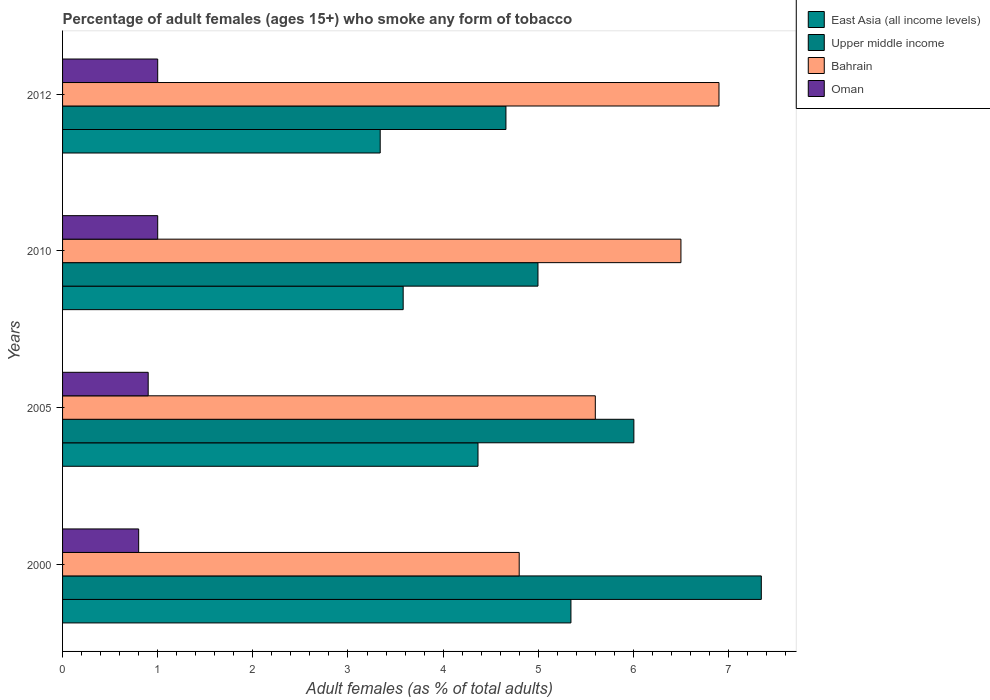How many different coloured bars are there?
Provide a succinct answer. 4. Are the number of bars per tick equal to the number of legend labels?
Your answer should be very brief. Yes. Are the number of bars on each tick of the Y-axis equal?
Your answer should be very brief. Yes. How many bars are there on the 3rd tick from the top?
Make the answer very short. 4. What is the label of the 4th group of bars from the top?
Offer a very short reply. 2000. In how many cases, is the number of bars for a given year not equal to the number of legend labels?
Offer a terse response. 0. What is the percentage of adult females who smoke in Upper middle income in 2000?
Offer a very short reply. 7.35. Across all years, what is the maximum percentage of adult females who smoke in East Asia (all income levels)?
Provide a short and direct response. 5.34. What is the difference between the percentage of adult females who smoke in Upper middle income in 2005 and that in 2012?
Ensure brevity in your answer.  1.34. What is the difference between the percentage of adult females who smoke in Bahrain in 2010 and the percentage of adult females who smoke in Upper middle income in 2005?
Your answer should be compact. 0.49. What is the average percentage of adult females who smoke in East Asia (all income levels) per year?
Keep it short and to the point. 4.16. In the year 2012, what is the difference between the percentage of adult females who smoke in Oman and percentage of adult females who smoke in East Asia (all income levels)?
Your answer should be compact. -2.34. In how many years, is the percentage of adult females who smoke in Upper middle income greater than 6.4 %?
Keep it short and to the point. 1. What is the ratio of the percentage of adult females who smoke in Bahrain in 2005 to that in 2012?
Ensure brevity in your answer.  0.81. Is the difference between the percentage of adult females who smoke in Oman in 2010 and 2012 greater than the difference between the percentage of adult females who smoke in East Asia (all income levels) in 2010 and 2012?
Ensure brevity in your answer.  No. What is the difference between the highest and the second highest percentage of adult females who smoke in Bahrain?
Provide a short and direct response. 0.4. What is the difference between the highest and the lowest percentage of adult females who smoke in Upper middle income?
Provide a succinct answer. 2.68. Is it the case that in every year, the sum of the percentage of adult females who smoke in Bahrain and percentage of adult females who smoke in East Asia (all income levels) is greater than the sum of percentage of adult females who smoke in Oman and percentage of adult females who smoke in Upper middle income?
Provide a succinct answer. Yes. What does the 4th bar from the top in 2010 represents?
Your answer should be very brief. East Asia (all income levels). What does the 4th bar from the bottom in 2000 represents?
Your answer should be very brief. Oman. Is it the case that in every year, the sum of the percentage of adult females who smoke in East Asia (all income levels) and percentage of adult females who smoke in Oman is greater than the percentage of adult females who smoke in Bahrain?
Ensure brevity in your answer.  No. How many bars are there?
Make the answer very short. 16. How many years are there in the graph?
Keep it short and to the point. 4. What is the difference between two consecutive major ticks on the X-axis?
Your answer should be compact. 1. Are the values on the major ticks of X-axis written in scientific E-notation?
Your answer should be compact. No. Does the graph contain any zero values?
Ensure brevity in your answer.  No. Where does the legend appear in the graph?
Your answer should be very brief. Top right. What is the title of the graph?
Keep it short and to the point. Percentage of adult females (ages 15+) who smoke any form of tobacco. Does "Iraq" appear as one of the legend labels in the graph?
Ensure brevity in your answer.  No. What is the label or title of the X-axis?
Offer a very short reply. Adult females (as % of total adults). What is the label or title of the Y-axis?
Offer a very short reply. Years. What is the Adult females (as % of total adults) of East Asia (all income levels) in 2000?
Your response must be concise. 5.34. What is the Adult females (as % of total adults) of Upper middle income in 2000?
Your response must be concise. 7.35. What is the Adult females (as % of total adults) of Oman in 2000?
Offer a terse response. 0.8. What is the Adult females (as % of total adults) of East Asia (all income levels) in 2005?
Your response must be concise. 4.37. What is the Adult females (as % of total adults) of Upper middle income in 2005?
Your answer should be compact. 6.01. What is the Adult females (as % of total adults) of Bahrain in 2005?
Give a very brief answer. 5.6. What is the Adult females (as % of total adults) of Oman in 2005?
Offer a terse response. 0.9. What is the Adult females (as % of total adults) of East Asia (all income levels) in 2010?
Make the answer very short. 3.58. What is the Adult females (as % of total adults) of Upper middle income in 2010?
Provide a succinct answer. 5. What is the Adult females (as % of total adults) of East Asia (all income levels) in 2012?
Make the answer very short. 3.34. What is the Adult females (as % of total adults) in Upper middle income in 2012?
Your answer should be very brief. 4.66. What is the Adult females (as % of total adults) in Bahrain in 2012?
Give a very brief answer. 6.9. Across all years, what is the maximum Adult females (as % of total adults) of East Asia (all income levels)?
Make the answer very short. 5.34. Across all years, what is the maximum Adult females (as % of total adults) of Upper middle income?
Your answer should be very brief. 7.35. Across all years, what is the maximum Adult females (as % of total adults) of Oman?
Provide a succinct answer. 1. Across all years, what is the minimum Adult females (as % of total adults) in East Asia (all income levels)?
Offer a terse response. 3.34. Across all years, what is the minimum Adult females (as % of total adults) in Upper middle income?
Provide a short and direct response. 4.66. Across all years, what is the minimum Adult females (as % of total adults) in Bahrain?
Provide a short and direct response. 4.8. What is the total Adult females (as % of total adults) in East Asia (all income levels) in the graph?
Give a very brief answer. 16.63. What is the total Adult females (as % of total adults) of Upper middle income in the graph?
Offer a very short reply. 23.01. What is the total Adult females (as % of total adults) of Bahrain in the graph?
Ensure brevity in your answer.  23.8. What is the difference between the Adult females (as % of total adults) of East Asia (all income levels) in 2000 and that in 2005?
Offer a terse response. 0.98. What is the difference between the Adult females (as % of total adults) of Upper middle income in 2000 and that in 2005?
Your response must be concise. 1.34. What is the difference between the Adult females (as % of total adults) of East Asia (all income levels) in 2000 and that in 2010?
Provide a short and direct response. 1.76. What is the difference between the Adult females (as % of total adults) in Upper middle income in 2000 and that in 2010?
Keep it short and to the point. 2.35. What is the difference between the Adult females (as % of total adults) of East Asia (all income levels) in 2000 and that in 2012?
Your answer should be compact. 2. What is the difference between the Adult females (as % of total adults) of Upper middle income in 2000 and that in 2012?
Provide a succinct answer. 2.68. What is the difference between the Adult females (as % of total adults) in Bahrain in 2000 and that in 2012?
Your answer should be very brief. -2.1. What is the difference between the Adult females (as % of total adults) in East Asia (all income levels) in 2005 and that in 2010?
Ensure brevity in your answer.  0.79. What is the difference between the Adult females (as % of total adults) in Upper middle income in 2005 and that in 2010?
Make the answer very short. 1.01. What is the difference between the Adult females (as % of total adults) in East Asia (all income levels) in 2005 and that in 2012?
Offer a terse response. 1.03. What is the difference between the Adult females (as % of total adults) in Upper middle income in 2005 and that in 2012?
Your answer should be compact. 1.34. What is the difference between the Adult females (as % of total adults) in Bahrain in 2005 and that in 2012?
Make the answer very short. -1.3. What is the difference between the Adult females (as % of total adults) in East Asia (all income levels) in 2010 and that in 2012?
Offer a terse response. 0.24. What is the difference between the Adult females (as % of total adults) of Upper middle income in 2010 and that in 2012?
Your answer should be very brief. 0.34. What is the difference between the Adult females (as % of total adults) in Bahrain in 2010 and that in 2012?
Provide a short and direct response. -0.4. What is the difference between the Adult females (as % of total adults) in East Asia (all income levels) in 2000 and the Adult females (as % of total adults) in Upper middle income in 2005?
Keep it short and to the point. -0.66. What is the difference between the Adult females (as % of total adults) of East Asia (all income levels) in 2000 and the Adult females (as % of total adults) of Bahrain in 2005?
Make the answer very short. -0.26. What is the difference between the Adult females (as % of total adults) in East Asia (all income levels) in 2000 and the Adult females (as % of total adults) in Oman in 2005?
Offer a very short reply. 4.44. What is the difference between the Adult females (as % of total adults) in Upper middle income in 2000 and the Adult females (as % of total adults) in Bahrain in 2005?
Provide a succinct answer. 1.75. What is the difference between the Adult females (as % of total adults) of Upper middle income in 2000 and the Adult females (as % of total adults) of Oman in 2005?
Provide a short and direct response. 6.45. What is the difference between the Adult females (as % of total adults) of Bahrain in 2000 and the Adult females (as % of total adults) of Oman in 2005?
Ensure brevity in your answer.  3.9. What is the difference between the Adult females (as % of total adults) of East Asia (all income levels) in 2000 and the Adult females (as % of total adults) of Upper middle income in 2010?
Your answer should be very brief. 0.35. What is the difference between the Adult females (as % of total adults) of East Asia (all income levels) in 2000 and the Adult females (as % of total adults) of Bahrain in 2010?
Keep it short and to the point. -1.16. What is the difference between the Adult females (as % of total adults) in East Asia (all income levels) in 2000 and the Adult females (as % of total adults) in Oman in 2010?
Offer a very short reply. 4.34. What is the difference between the Adult females (as % of total adults) in Upper middle income in 2000 and the Adult females (as % of total adults) in Bahrain in 2010?
Offer a terse response. 0.84. What is the difference between the Adult females (as % of total adults) in Upper middle income in 2000 and the Adult females (as % of total adults) in Oman in 2010?
Your answer should be very brief. 6.34. What is the difference between the Adult females (as % of total adults) in East Asia (all income levels) in 2000 and the Adult females (as % of total adults) in Upper middle income in 2012?
Provide a short and direct response. 0.68. What is the difference between the Adult females (as % of total adults) in East Asia (all income levels) in 2000 and the Adult females (as % of total adults) in Bahrain in 2012?
Keep it short and to the point. -1.56. What is the difference between the Adult females (as % of total adults) of East Asia (all income levels) in 2000 and the Adult females (as % of total adults) of Oman in 2012?
Give a very brief answer. 4.34. What is the difference between the Adult females (as % of total adults) in Upper middle income in 2000 and the Adult females (as % of total adults) in Bahrain in 2012?
Provide a short and direct response. 0.45. What is the difference between the Adult females (as % of total adults) of Upper middle income in 2000 and the Adult females (as % of total adults) of Oman in 2012?
Give a very brief answer. 6.34. What is the difference between the Adult females (as % of total adults) in Bahrain in 2000 and the Adult females (as % of total adults) in Oman in 2012?
Your answer should be very brief. 3.8. What is the difference between the Adult females (as % of total adults) of East Asia (all income levels) in 2005 and the Adult females (as % of total adults) of Upper middle income in 2010?
Keep it short and to the point. -0.63. What is the difference between the Adult females (as % of total adults) in East Asia (all income levels) in 2005 and the Adult females (as % of total adults) in Bahrain in 2010?
Offer a very short reply. -2.13. What is the difference between the Adult females (as % of total adults) of East Asia (all income levels) in 2005 and the Adult females (as % of total adults) of Oman in 2010?
Offer a terse response. 3.37. What is the difference between the Adult females (as % of total adults) of Upper middle income in 2005 and the Adult females (as % of total adults) of Bahrain in 2010?
Provide a succinct answer. -0.49. What is the difference between the Adult females (as % of total adults) in Upper middle income in 2005 and the Adult females (as % of total adults) in Oman in 2010?
Ensure brevity in your answer.  5.01. What is the difference between the Adult females (as % of total adults) in Bahrain in 2005 and the Adult females (as % of total adults) in Oman in 2010?
Make the answer very short. 4.6. What is the difference between the Adult females (as % of total adults) of East Asia (all income levels) in 2005 and the Adult females (as % of total adults) of Upper middle income in 2012?
Your answer should be compact. -0.29. What is the difference between the Adult females (as % of total adults) in East Asia (all income levels) in 2005 and the Adult females (as % of total adults) in Bahrain in 2012?
Offer a very short reply. -2.53. What is the difference between the Adult females (as % of total adults) in East Asia (all income levels) in 2005 and the Adult females (as % of total adults) in Oman in 2012?
Your response must be concise. 3.37. What is the difference between the Adult females (as % of total adults) of Upper middle income in 2005 and the Adult females (as % of total adults) of Bahrain in 2012?
Ensure brevity in your answer.  -0.89. What is the difference between the Adult females (as % of total adults) in Upper middle income in 2005 and the Adult females (as % of total adults) in Oman in 2012?
Give a very brief answer. 5.01. What is the difference between the Adult females (as % of total adults) of Bahrain in 2005 and the Adult females (as % of total adults) of Oman in 2012?
Your answer should be very brief. 4.6. What is the difference between the Adult females (as % of total adults) of East Asia (all income levels) in 2010 and the Adult females (as % of total adults) of Upper middle income in 2012?
Your response must be concise. -1.08. What is the difference between the Adult females (as % of total adults) of East Asia (all income levels) in 2010 and the Adult females (as % of total adults) of Bahrain in 2012?
Keep it short and to the point. -3.32. What is the difference between the Adult females (as % of total adults) of East Asia (all income levels) in 2010 and the Adult females (as % of total adults) of Oman in 2012?
Keep it short and to the point. 2.58. What is the difference between the Adult females (as % of total adults) of Upper middle income in 2010 and the Adult females (as % of total adults) of Bahrain in 2012?
Keep it short and to the point. -1.9. What is the difference between the Adult females (as % of total adults) of Upper middle income in 2010 and the Adult females (as % of total adults) of Oman in 2012?
Make the answer very short. 4. What is the difference between the Adult females (as % of total adults) of Bahrain in 2010 and the Adult females (as % of total adults) of Oman in 2012?
Ensure brevity in your answer.  5.5. What is the average Adult females (as % of total adults) in East Asia (all income levels) per year?
Make the answer very short. 4.16. What is the average Adult females (as % of total adults) in Upper middle income per year?
Your response must be concise. 5.75. What is the average Adult females (as % of total adults) in Bahrain per year?
Offer a very short reply. 5.95. What is the average Adult females (as % of total adults) in Oman per year?
Provide a succinct answer. 0.93. In the year 2000, what is the difference between the Adult females (as % of total adults) of East Asia (all income levels) and Adult females (as % of total adults) of Upper middle income?
Make the answer very short. -2. In the year 2000, what is the difference between the Adult females (as % of total adults) of East Asia (all income levels) and Adult females (as % of total adults) of Bahrain?
Your answer should be very brief. 0.54. In the year 2000, what is the difference between the Adult females (as % of total adults) of East Asia (all income levels) and Adult females (as % of total adults) of Oman?
Your response must be concise. 4.54. In the year 2000, what is the difference between the Adult females (as % of total adults) of Upper middle income and Adult females (as % of total adults) of Bahrain?
Provide a short and direct response. 2.54. In the year 2000, what is the difference between the Adult females (as % of total adults) in Upper middle income and Adult females (as % of total adults) in Oman?
Keep it short and to the point. 6.54. In the year 2000, what is the difference between the Adult females (as % of total adults) of Bahrain and Adult females (as % of total adults) of Oman?
Your answer should be very brief. 4. In the year 2005, what is the difference between the Adult females (as % of total adults) in East Asia (all income levels) and Adult females (as % of total adults) in Upper middle income?
Provide a short and direct response. -1.64. In the year 2005, what is the difference between the Adult females (as % of total adults) in East Asia (all income levels) and Adult females (as % of total adults) in Bahrain?
Your answer should be compact. -1.23. In the year 2005, what is the difference between the Adult females (as % of total adults) of East Asia (all income levels) and Adult females (as % of total adults) of Oman?
Keep it short and to the point. 3.47. In the year 2005, what is the difference between the Adult females (as % of total adults) in Upper middle income and Adult females (as % of total adults) in Bahrain?
Keep it short and to the point. 0.41. In the year 2005, what is the difference between the Adult females (as % of total adults) in Upper middle income and Adult females (as % of total adults) in Oman?
Your response must be concise. 5.11. In the year 2005, what is the difference between the Adult females (as % of total adults) in Bahrain and Adult females (as % of total adults) in Oman?
Your response must be concise. 4.7. In the year 2010, what is the difference between the Adult females (as % of total adults) of East Asia (all income levels) and Adult females (as % of total adults) of Upper middle income?
Keep it short and to the point. -1.42. In the year 2010, what is the difference between the Adult females (as % of total adults) of East Asia (all income levels) and Adult females (as % of total adults) of Bahrain?
Provide a succinct answer. -2.92. In the year 2010, what is the difference between the Adult females (as % of total adults) of East Asia (all income levels) and Adult females (as % of total adults) of Oman?
Provide a short and direct response. 2.58. In the year 2010, what is the difference between the Adult females (as % of total adults) of Upper middle income and Adult females (as % of total adults) of Bahrain?
Provide a short and direct response. -1.5. In the year 2010, what is the difference between the Adult females (as % of total adults) of Upper middle income and Adult females (as % of total adults) of Oman?
Give a very brief answer. 4. In the year 2010, what is the difference between the Adult females (as % of total adults) in Bahrain and Adult females (as % of total adults) in Oman?
Provide a short and direct response. 5.5. In the year 2012, what is the difference between the Adult females (as % of total adults) of East Asia (all income levels) and Adult females (as % of total adults) of Upper middle income?
Your response must be concise. -1.32. In the year 2012, what is the difference between the Adult females (as % of total adults) in East Asia (all income levels) and Adult females (as % of total adults) in Bahrain?
Provide a succinct answer. -3.56. In the year 2012, what is the difference between the Adult females (as % of total adults) in East Asia (all income levels) and Adult females (as % of total adults) in Oman?
Your answer should be compact. 2.34. In the year 2012, what is the difference between the Adult females (as % of total adults) of Upper middle income and Adult females (as % of total adults) of Bahrain?
Give a very brief answer. -2.24. In the year 2012, what is the difference between the Adult females (as % of total adults) in Upper middle income and Adult females (as % of total adults) in Oman?
Offer a very short reply. 3.66. In the year 2012, what is the difference between the Adult females (as % of total adults) of Bahrain and Adult females (as % of total adults) of Oman?
Keep it short and to the point. 5.9. What is the ratio of the Adult females (as % of total adults) in East Asia (all income levels) in 2000 to that in 2005?
Provide a succinct answer. 1.22. What is the ratio of the Adult females (as % of total adults) of Upper middle income in 2000 to that in 2005?
Give a very brief answer. 1.22. What is the ratio of the Adult females (as % of total adults) in Bahrain in 2000 to that in 2005?
Your answer should be very brief. 0.86. What is the ratio of the Adult females (as % of total adults) in Oman in 2000 to that in 2005?
Your answer should be very brief. 0.89. What is the ratio of the Adult females (as % of total adults) of East Asia (all income levels) in 2000 to that in 2010?
Offer a very short reply. 1.49. What is the ratio of the Adult females (as % of total adults) of Upper middle income in 2000 to that in 2010?
Your response must be concise. 1.47. What is the ratio of the Adult females (as % of total adults) in Bahrain in 2000 to that in 2010?
Offer a very short reply. 0.74. What is the ratio of the Adult females (as % of total adults) in Oman in 2000 to that in 2010?
Ensure brevity in your answer.  0.8. What is the ratio of the Adult females (as % of total adults) in East Asia (all income levels) in 2000 to that in 2012?
Your answer should be compact. 1.6. What is the ratio of the Adult females (as % of total adults) of Upper middle income in 2000 to that in 2012?
Offer a very short reply. 1.58. What is the ratio of the Adult females (as % of total adults) in Bahrain in 2000 to that in 2012?
Offer a terse response. 0.7. What is the ratio of the Adult females (as % of total adults) in East Asia (all income levels) in 2005 to that in 2010?
Your answer should be compact. 1.22. What is the ratio of the Adult females (as % of total adults) in Upper middle income in 2005 to that in 2010?
Your response must be concise. 1.2. What is the ratio of the Adult females (as % of total adults) of Bahrain in 2005 to that in 2010?
Keep it short and to the point. 0.86. What is the ratio of the Adult females (as % of total adults) in East Asia (all income levels) in 2005 to that in 2012?
Provide a succinct answer. 1.31. What is the ratio of the Adult females (as % of total adults) of Upper middle income in 2005 to that in 2012?
Provide a succinct answer. 1.29. What is the ratio of the Adult females (as % of total adults) of Bahrain in 2005 to that in 2012?
Offer a terse response. 0.81. What is the ratio of the Adult females (as % of total adults) of East Asia (all income levels) in 2010 to that in 2012?
Make the answer very short. 1.07. What is the ratio of the Adult females (as % of total adults) of Upper middle income in 2010 to that in 2012?
Offer a very short reply. 1.07. What is the ratio of the Adult females (as % of total adults) of Bahrain in 2010 to that in 2012?
Provide a short and direct response. 0.94. What is the difference between the highest and the second highest Adult females (as % of total adults) of East Asia (all income levels)?
Offer a very short reply. 0.98. What is the difference between the highest and the second highest Adult females (as % of total adults) in Upper middle income?
Give a very brief answer. 1.34. What is the difference between the highest and the second highest Adult females (as % of total adults) in Bahrain?
Make the answer very short. 0.4. What is the difference between the highest and the lowest Adult females (as % of total adults) of East Asia (all income levels)?
Provide a short and direct response. 2. What is the difference between the highest and the lowest Adult females (as % of total adults) in Upper middle income?
Ensure brevity in your answer.  2.68. What is the difference between the highest and the lowest Adult females (as % of total adults) of Bahrain?
Your answer should be very brief. 2.1. What is the difference between the highest and the lowest Adult females (as % of total adults) in Oman?
Provide a short and direct response. 0.2. 